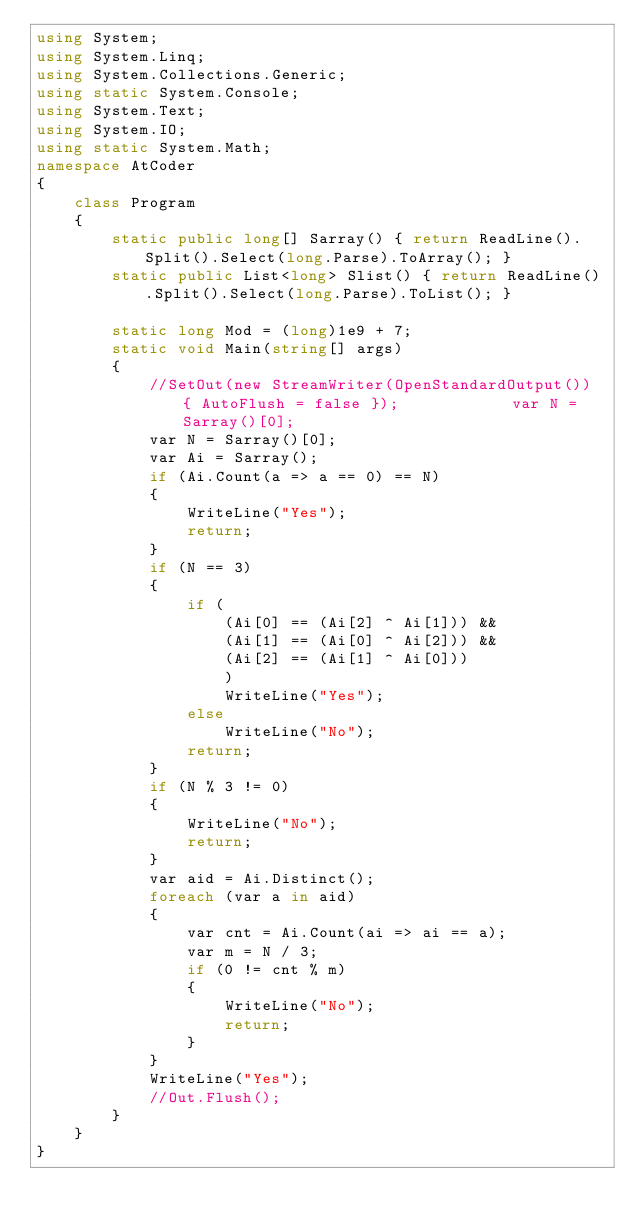<code> <loc_0><loc_0><loc_500><loc_500><_C#_>using System;
using System.Linq;
using System.Collections.Generic;
using static System.Console;
using System.Text;
using System.IO;
using static System.Math;
namespace AtCoder
{
    class Program
    {
        static public long[] Sarray() { return ReadLine().Split().Select(long.Parse).ToArray(); }
        static public List<long> Slist() { return ReadLine().Split().Select(long.Parse).ToList(); }

        static long Mod = (long)1e9 + 7;
        static void Main(string[] args)
        {
            //SetOut(new StreamWriter(OpenStandardOutput()) { AutoFlush = false });            var N = Sarray()[0];
            var N = Sarray()[0];
            var Ai = Sarray();
            if (Ai.Count(a => a == 0) == N)
            {
                WriteLine("Yes");
                return;
            }
            if (N == 3)
            {
                if (
                    (Ai[0] == (Ai[2] ^ Ai[1])) &&
                    (Ai[1] == (Ai[0] ^ Ai[2])) &&
                    (Ai[2] == (Ai[1] ^ Ai[0]))
                    )
                    WriteLine("Yes");
                else
                    WriteLine("No");
                return;
            }
            if (N % 3 != 0)
            {
                WriteLine("No");
                return;
            }
            var aid = Ai.Distinct();
            foreach (var a in aid)
            {
                var cnt = Ai.Count(ai => ai == a);
                var m = N / 3;
                if (0 != cnt % m)
                {
                    WriteLine("No");
                    return;
                }
            }
            WriteLine("Yes");
            //Out.Flush();
        }
    }
}</code> 